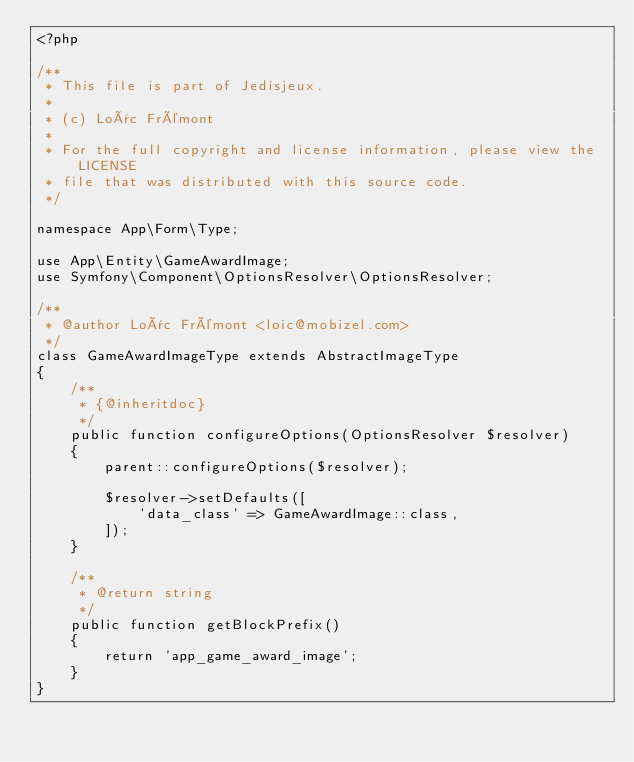Convert code to text. <code><loc_0><loc_0><loc_500><loc_500><_PHP_><?php

/**
 * This file is part of Jedisjeux.
 *
 * (c) Loïc Frémont
 *
 * For the full copyright and license information, please view the LICENSE
 * file that was distributed with this source code.
 */

namespace App\Form\Type;

use App\Entity\GameAwardImage;
use Symfony\Component\OptionsResolver\OptionsResolver;

/**
 * @author Loïc Frémont <loic@mobizel.com>
 */
class GameAwardImageType extends AbstractImageType
{
    /**
     * {@inheritdoc}
     */
    public function configureOptions(OptionsResolver $resolver)
    {
        parent::configureOptions($resolver);

        $resolver->setDefaults([
            'data_class' => GameAwardImage::class,
        ]);
    }

    /**
     * @return string
     */
    public function getBlockPrefix()
    {
        return 'app_game_award_image';
    }
}
</code> 